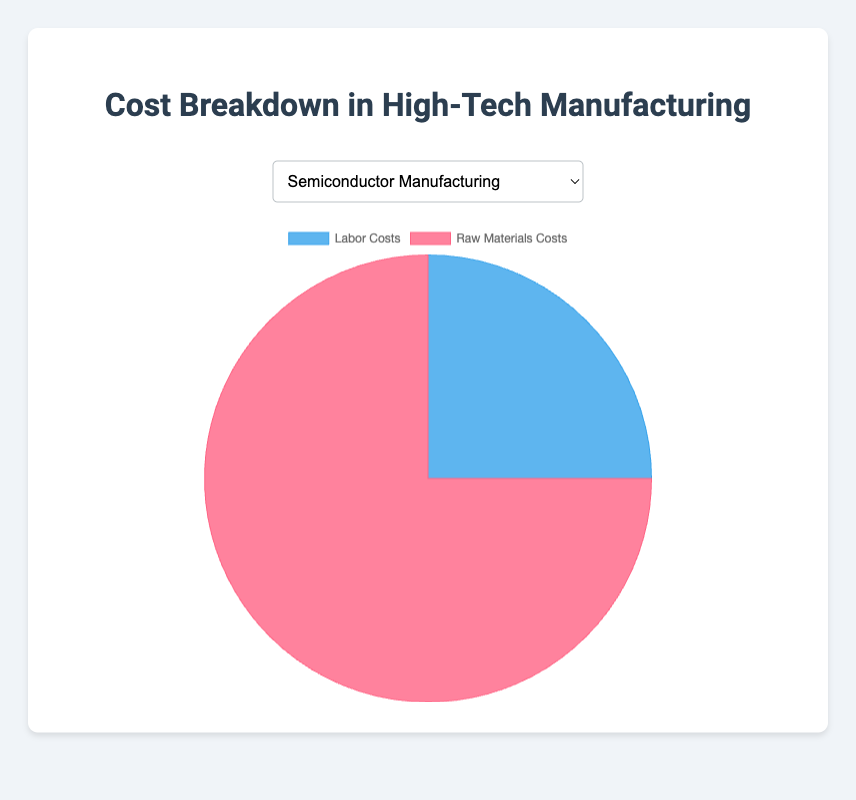Does Semiconductor Manufacturing have a higher percentage of labor costs or raw materials costs? By looking at the pie chart for Semiconductor Manufacturing, we can see the breakdown of costs. The percentage of raw materials costs (75%) is higher than the percentage of labor costs (25%).
Answer: Raw materials costs What is the difference in labor costs percentage between Aerospace Manufacturing and Robotics Manufacturing? From the chart, Aerospace Manufacturing has 30% labor costs, while Robotics Manufacturing has 35%. The difference is 35% - 30% = 5%.
Answer: 5% In Medical Devices Manufacturing, is the proportion of raw materials costs more than three times the proportion of labor costs? The labor costs in Medical Devices Manufacturing are 20%, and the raw materials costs are 80%. To see if raw materials are more than three times labor: 20% * 3 = 60%. Since 80% is more than 60%, the raw materials costs are more than three times the labor costs.
Answer: Yes Which industry has the closest proportion of labor costs and raw materials costs? By observing the proportions for all industries, Robotics Manufacturing has labor costs at 35% and raw materials at 65%, which are the most balanced percentages among the given industries.
Answer: Robotics Manufacturing Among the given industries, in which industry do raw materials costs constitute the smallest proportion of the total production costs? By looking at the chart, raw materials costs are represented by the red segment. The Semiconductor Manufacturing industry has the smallest proportion at 75% raw materials costs.
Answer: Semiconductor Manufacturing If you sum the labor costs percentages of Aerospace, Robotics, and Automotive Electronics Manufacturing industries, what is the total percentage? Aerospace: 30%, Robotics: 35%, Automotive Electronics: 28%. Summing these gives 30% + 35% + 28% = 93%.
Answer: 93% What is the average percentage of raw materials costs across all industries? To calculate the average, sum up the raw materials costs percentages: 75% + 70% + 65% + 80% + 72% = 362%. Then divide by the number of industries (5): 362% / 5 = 72.4%.
Answer: 72.4% If an industry had an equal split between labor costs and raw materials costs, how would the pie chart look visually? An equal split would mean each segment takes up 50% of the pie chart. Visually, the pie chart would be split into two equal semi-circular sections, one representing labor costs and the other representing raw materials costs.
Answer: Two equal semi-circular sections What is the range of labor costs percentages among all the industries in the data provided? The labor costs percentages range from a minimum of 20% (Medical Devices Manufacturing) to a maximum of 35% (Robotics Manufacturing). The range is 35% - 20% = 15%.
Answer: 15% 